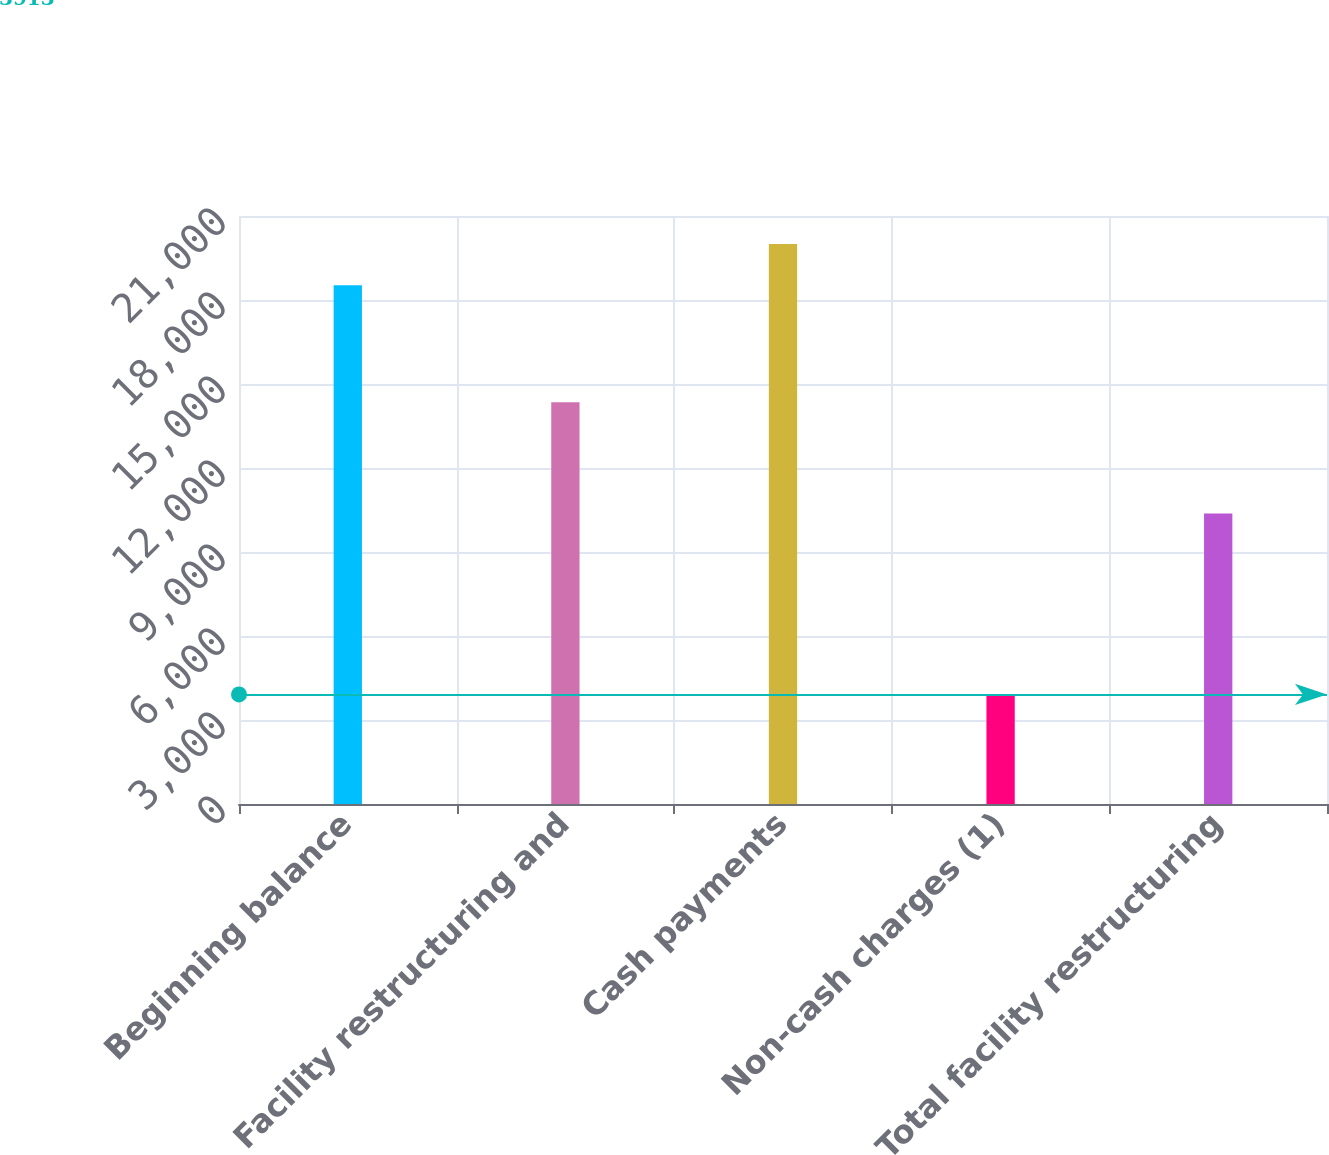Convert chart. <chart><loc_0><loc_0><loc_500><loc_500><bar_chart><fcel>Beginning balance<fcel>Facility restructuring and<fcel>Cash payments<fcel>Non-cash charges (1)<fcel>Total facility restructuring<nl><fcel>18529<fcel>14346<fcel>19996.8<fcel>3913<fcel>10371<nl></chart> 